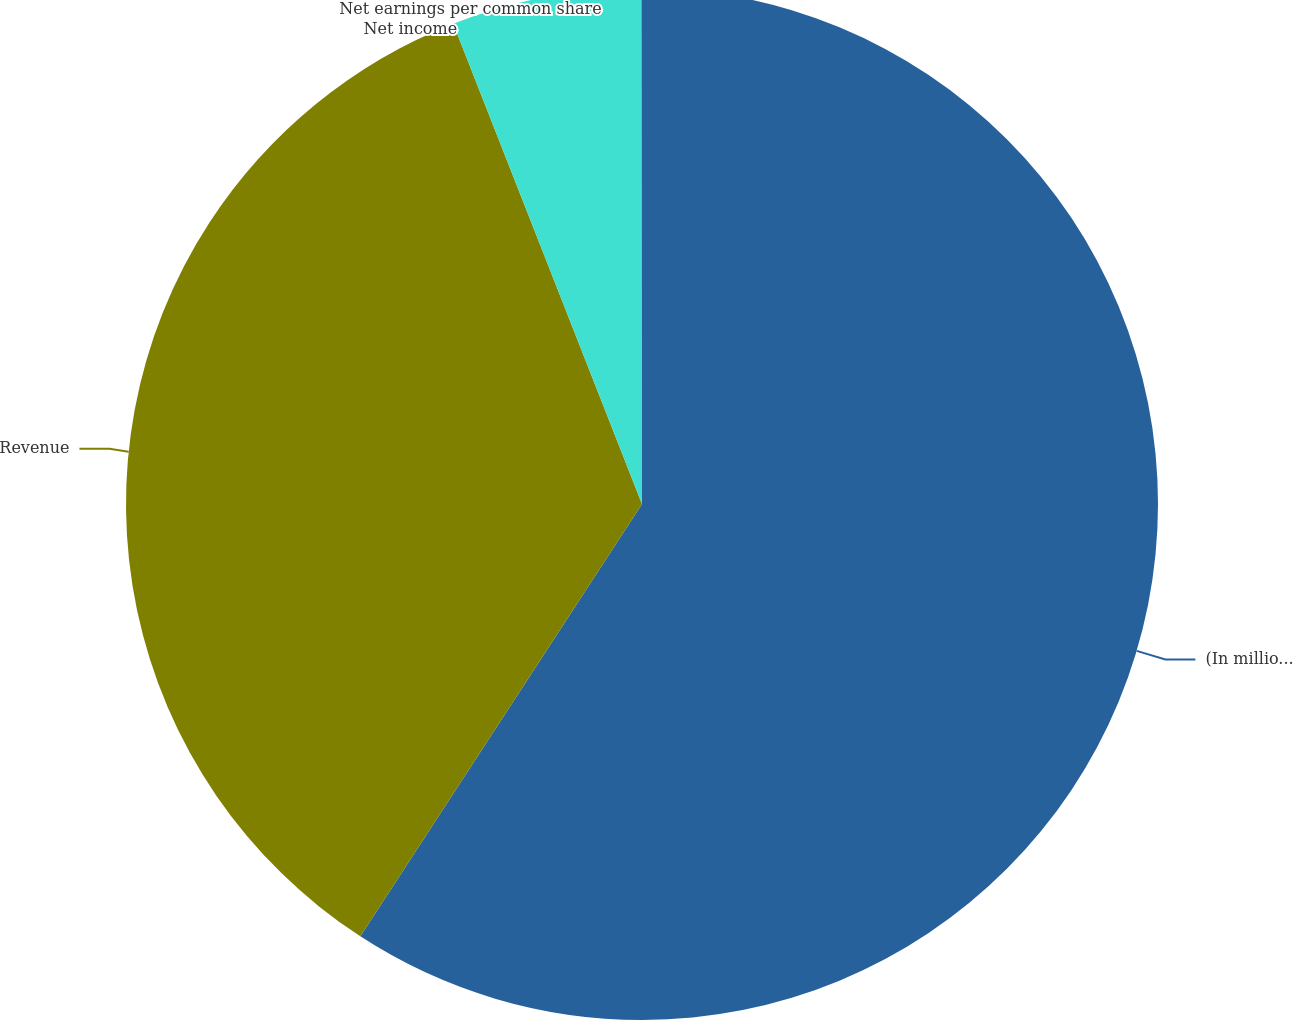Convert chart to OTSL. <chart><loc_0><loc_0><loc_500><loc_500><pie_chart><fcel>(In millions except per share<fcel>Revenue<fcel>Net income<fcel>Net earnings per common share<nl><fcel>59.19%<fcel>34.85%<fcel>5.94%<fcel>0.02%<nl></chart> 